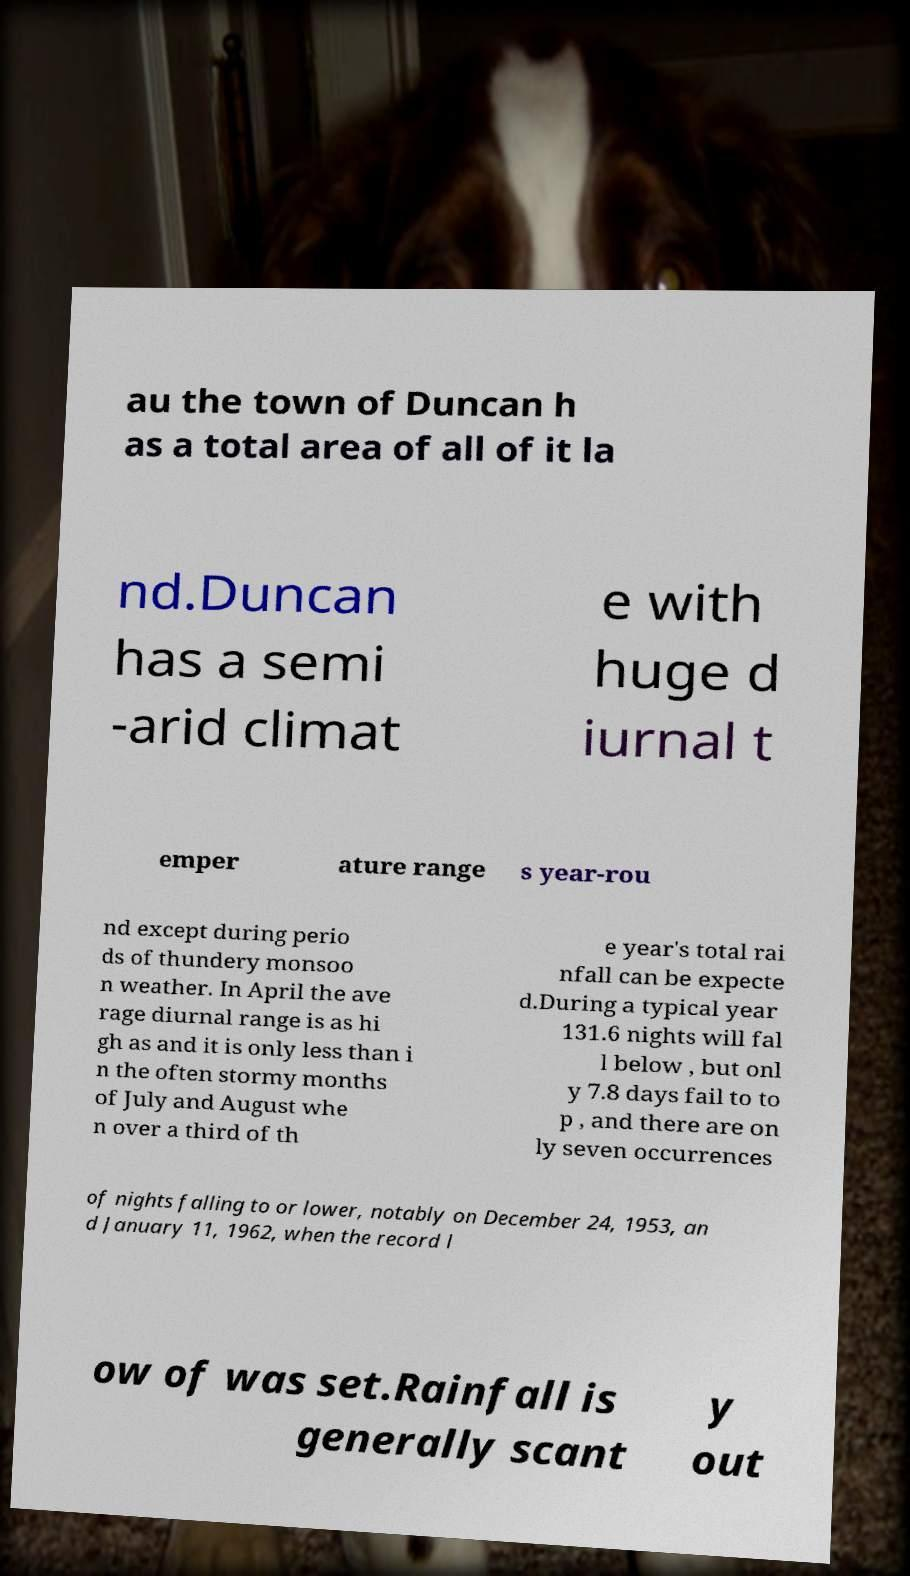There's text embedded in this image that I need extracted. Can you transcribe it verbatim? au the town of Duncan h as a total area of all of it la nd.Duncan has a semi -arid climat e with huge d iurnal t emper ature range s year-rou nd except during perio ds of thundery monsoo n weather. In April the ave rage diurnal range is as hi gh as and it is only less than i n the often stormy months of July and August whe n over a third of th e year's total rai nfall can be expecte d.During a typical year 131.6 nights will fal l below , but onl y 7.8 days fail to to p , and there are on ly seven occurrences of nights falling to or lower, notably on December 24, 1953, an d January 11, 1962, when the record l ow of was set.Rainfall is generally scant y out 